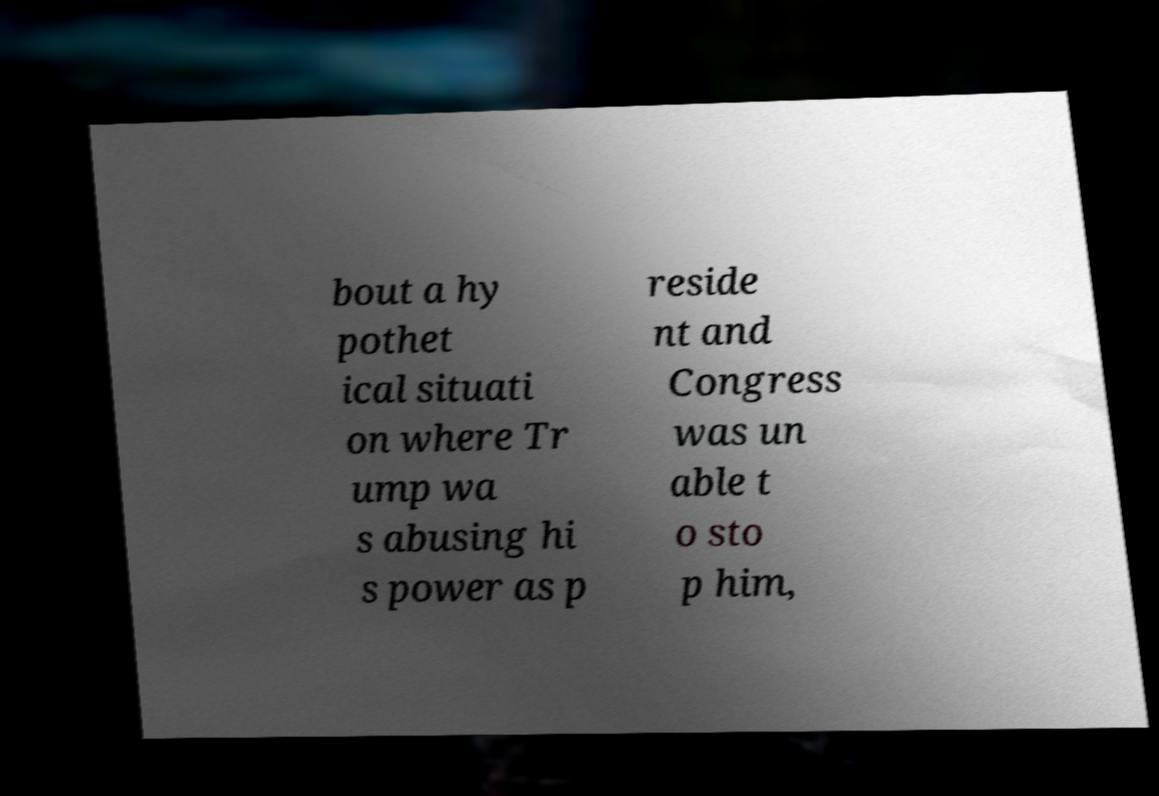I need the written content from this picture converted into text. Can you do that? bout a hy pothet ical situati on where Tr ump wa s abusing hi s power as p reside nt and Congress was un able t o sto p him, 